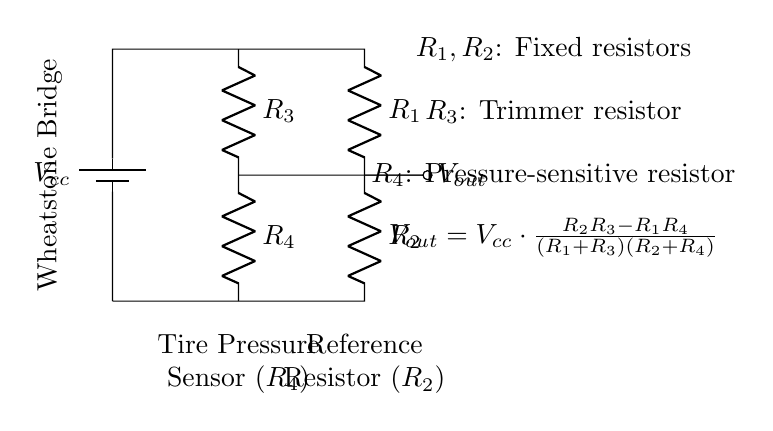What type of circuit is depicted? The circuit shown is a Wheatstone bridge, which is characterized by its arrangement of resistors that is typically used for measuring resistance or voltage.
Answer: Wheatstone bridge What are the names of the resistors in the circuit? The resistors in the circuit are labeled as R1, R2, R3, and R4. Each serves a specific function in the Wheatstone bridge configuration.
Answer: R1, R2, R3, R4 What does the output voltage depend on? The output voltage, Vout, depends on the values of the resistors R1, R2, R3, and R4, as indicated by the equation given in the circuit diagram.
Answer: The resistors' values What is the role of R4 in the circuit? R4 is labeled as the pressure-sensitive resistor, which acts as the tire pressure sensor in this Wheatstone bridge setup.
Answer: Tire pressure sensor How does Vout change with varying pressure? As pressure changes, R4 changes its resistance, which alters the balance of the bridge and consequently Vout based on the provided equation.
Answer: It changes according to resistance What is the function of R3 in this circuit? R3 is a trimmer resistor, which allows for fine adjustments to maintain the balance of the bridge for accurate readings.
Answer: Fine adjustments 